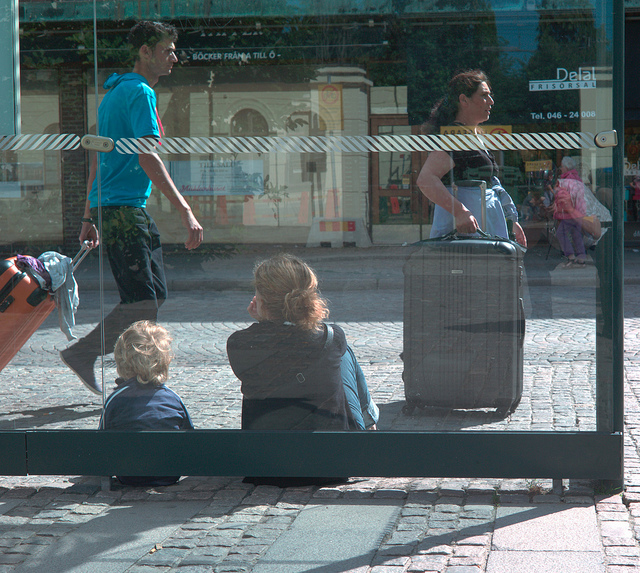Please extract the text content from this image. FRAMA 24000 046 Tol erisorsal Delal 